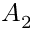<formula> <loc_0><loc_0><loc_500><loc_500>A _ { 2 }</formula> 